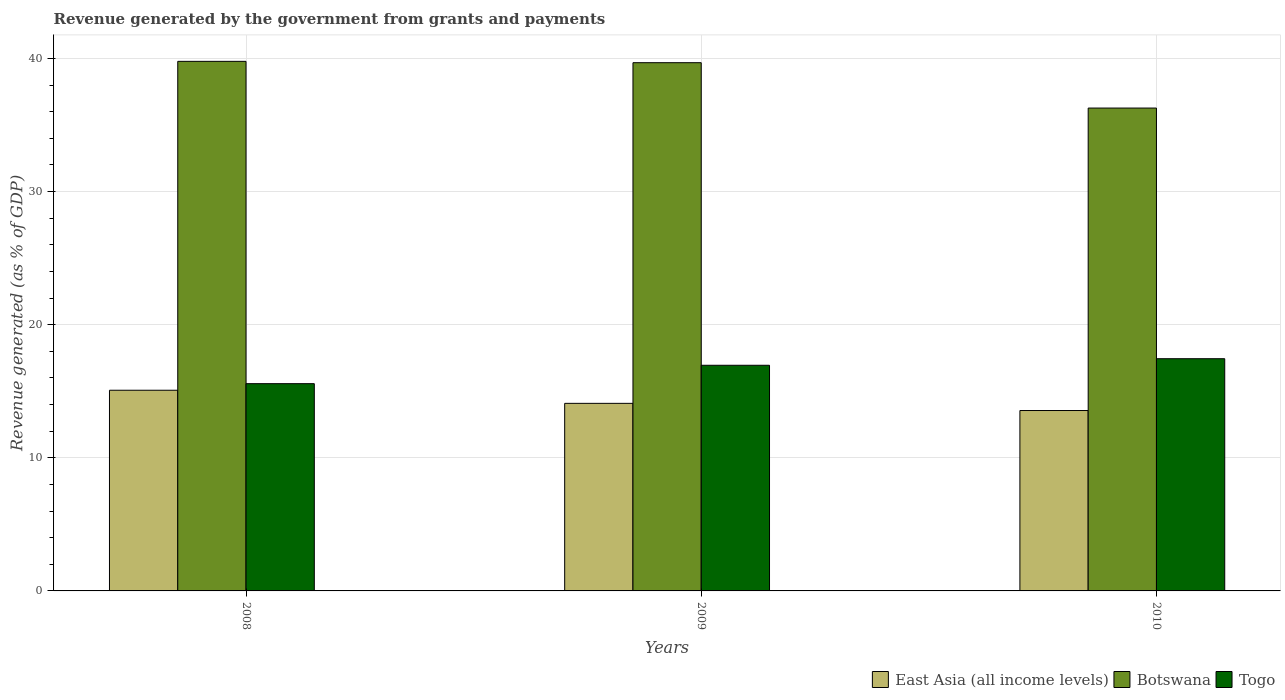How many different coloured bars are there?
Give a very brief answer. 3. What is the label of the 2nd group of bars from the left?
Provide a succinct answer. 2009. In how many cases, is the number of bars for a given year not equal to the number of legend labels?
Keep it short and to the point. 0. What is the revenue generated by the government in Togo in 2010?
Provide a succinct answer. 17.44. Across all years, what is the maximum revenue generated by the government in Botswana?
Your answer should be compact. 39.78. Across all years, what is the minimum revenue generated by the government in East Asia (all income levels)?
Give a very brief answer. 13.55. In which year was the revenue generated by the government in Botswana maximum?
Provide a short and direct response. 2008. In which year was the revenue generated by the government in East Asia (all income levels) minimum?
Provide a short and direct response. 2010. What is the total revenue generated by the government in Botswana in the graph?
Give a very brief answer. 115.74. What is the difference between the revenue generated by the government in East Asia (all income levels) in 2008 and that in 2009?
Give a very brief answer. 0.99. What is the difference between the revenue generated by the government in Togo in 2008 and the revenue generated by the government in Botswana in 2009?
Your answer should be very brief. -24.11. What is the average revenue generated by the government in Botswana per year?
Your answer should be very brief. 38.58. In the year 2010, what is the difference between the revenue generated by the government in Botswana and revenue generated by the government in Togo?
Offer a terse response. 18.83. In how many years, is the revenue generated by the government in East Asia (all income levels) greater than 10 %?
Your answer should be compact. 3. What is the ratio of the revenue generated by the government in Togo in 2009 to that in 2010?
Give a very brief answer. 0.97. What is the difference between the highest and the second highest revenue generated by the government in Togo?
Offer a very short reply. 0.49. What is the difference between the highest and the lowest revenue generated by the government in Togo?
Give a very brief answer. 1.87. In how many years, is the revenue generated by the government in East Asia (all income levels) greater than the average revenue generated by the government in East Asia (all income levels) taken over all years?
Make the answer very short. 1. Is the sum of the revenue generated by the government in Botswana in 2009 and 2010 greater than the maximum revenue generated by the government in Togo across all years?
Keep it short and to the point. Yes. What does the 3rd bar from the left in 2008 represents?
Your response must be concise. Togo. What does the 1st bar from the right in 2008 represents?
Give a very brief answer. Togo. Is it the case that in every year, the sum of the revenue generated by the government in Botswana and revenue generated by the government in East Asia (all income levels) is greater than the revenue generated by the government in Togo?
Your answer should be very brief. Yes. How many bars are there?
Make the answer very short. 9. Are all the bars in the graph horizontal?
Make the answer very short. No. How many years are there in the graph?
Your answer should be compact. 3. Are the values on the major ticks of Y-axis written in scientific E-notation?
Ensure brevity in your answer.  No. Does the graph contain grids?
Make the answer very short. Yes. Where does the legend appear in the graph?
Give a very brief answer. Bottom right. How many legend labels are there?
Ensure brevity in your answer.  3. How are the legend labels stacked?
Keep it short and to the point. Horizontal. What is the title of the graph?
Provide a short and direct response. Revenue generated by the government from grants and payments. Does "Algeria" appear as one of the legend labels in the graph?
Your response must be concise. No. What is the label or title of the Y-axis?
Keep it short and to the point. Revenue generated (as % of GDP). What is the Revenue generated (as % of GDP) in East Asia (all income levels) in 2008?
Your response must be concise. 15.07. What is the Revenue generated (as % of GDP) of Botswana in 2008?
Ensure brevity in your answer.  39.78. What is the Revenue generated (as % of GDP) in Togo in 2008?
Your answer should be very brief. 15.57. What is the Revenue generated (as % of GDP) in East Asia (all income levels) in 2009?
Ensure brevity in your answer.  14.09. What is the Revenue generated (as % of GDP) in Botswana in 2009?
Your response must be concise. 39.68. What is the Revenue generated (as % of GDP) of Togo in 2009?
Ensure brevity in your answer.  16.95. What is the Revenue generated (as % of GDP) in East Asia (all income levels) in 2010?
Ensure brevity in your answer.  13.55. What is the Revenue generated (as % of GDP) in Botswana in 2010?
Provide a succinct answer. 36.27. What is the Revenue generated (as % of GDP) of Togo in 2010?
Keep it short and to the point. 17.44. Across all years, what is the maximum Revenue generated (as % of GDP) of East Asia (all income levels)?
Provide a short and direct response. 15.07. Across all years, what is the maximum Revenue generated (as % of GDP) of Botswana?
Provide a succinct answer. 39.78. Across all years, what is the maximum Revenue generated (as % of GDP) in Togo?
Your answer should be compact. 17.44. Across all years, what is the minimum Revenue generated (as % of GDP) in East Asia (all income levels)?
Your answer should be compact. 13.55. Across all years, what is the minimum Revenue generated (as % of GDP) in Botswana?
Offer a very short reply. 36.27. Across all years, what is the minimum Revenue generated (as % of GDP) of Togo?
Offer a terse response. 15.57. What is the total Revenue generated (as % of GDP) in East Asia (all income levels) in the graph?
Make the answer very short. 42.72. What is the total Revenue generated (as % of GDP) of Botswana in the graph?
Keep it short and to the point. 115.74. What is the total Revenue generated (as % of GDP) of Togo in the graph?
Provide a succinct answer. 49.96. What is the difference between the Revenue generated (as % of GDP) of East Asia (all income levels) in 2008 and that in 2009?
Your answer should be compact. 0.99. What is the difference between the Revenue generated (as % of GDP) of Botswana in 2008 and that in 2009?
Your answer should be very brief. 0.1. What is the difference between the Revenue generated (as % of GDP) in Togo in 2008 and that in 2009?
Offer a terse response. -1.38. What is the difference between the Revenue generated (as % of GDP) of East Asia (all income levels) in 2008 and that in 2010?
Your answer should be compact. 1.52. What is the difference between the Revenue generated (as % of GDP) in Botswana in 2008 and that in 2010?
Keep it short and to the point. 3.51. What is the difference between the Revenue generated (as % of GDP) in Togo in 2008 and that in 2010?
Make the answer very short. -1.87. What is the difference between the Revenue generated (as % of GDP) in East Asia (all income levels) in 2009 and that in 2010?
Provide a short and direct response. 0.54. What is the difference between the Revenue generated (as % of GDP) of Botswana in 2009 and that in 2010?
Ensure brevity in your answer.  3.41. What is the difference between the Revenue generated (as % of GDP) of Togo in 2009 and that in 2010?
Ensure brevity in your answer.  -0.49. What is the difference between the Revenue generated (as % of GDP) in East Asia (all income levels) in 2008 and the Revenue generated (as % of GDP) in Botswana in 2009?
Keep it short and to the point. -24.61. What is the difference between the Revenue generated (as % of GDP) of East Asia (all income levels) in 2008 and the Revenue generated (as % of GDP) of Togo in 2009?
Offer a terse response. -1.88. What is the difference between the Revenue generated (as % of GDP) of Botswana in 2008 and the Revenue generated (as % of GDP) of Togo in 2009?
Provide a short and direct response. 22.83. What is the difference between the Revenue generated (as % of GDP) in East Asia (all income levels) in 2008 and the Revenue generated (as % of GDP) in Botswana in 2010?
Make the answer very short. -21.2. What is the difference between the Revenue generated (as % of GDP) in East Asia (all income levels) in 2008 and the Revenue generated (as % of GDP) in Togo in 2010?
Provide a succinct answer. -2.37. What is the difference between the Revenue generated (as % of GDP) of Botswana in 2008 and the Revenue generated (as % of GDP) of Togo in 2010?
Your response must be concise. 22.34. What is the difference between the Revenue generated (as % of GDP) in East Asia (all income levels) in 2009 and the Revenue generated (as % of GDP) in Botswana in 2010?
Provide a succinct answer. -22.18. What is the difference between the Revenue generated (as % of GDP) in East Asia (all income levels) in 2009 and the Revenue generated (as % of GDP) in Togo in 2010?
Give a very brief answer. -3.35. What is the difference between the Revenue generated (as % of GDP) of Botswana in 2009 and the Revenue generated (as % of GDP) of Togo in 2010?
Provide a short and direct response. 22.24. What is the average Revenue generated (as % of GDP) of East Asia (all income levels) per year?
Provide a short and direct response. 14.24. What is the average Revenue generated (as % of GDP) in Botswana per year?
Offer a very short reply. 38.58. What is the average Revenue generated (as % of GDP) in Togo per year?
Ensure brevity in your answer.  16.65. In the year 2008, what is the difference between the Revenue generated (as % of GDP) in East Asia (all income levels) and Revenue generated (as % of GDP) in Botswana?
Your response must be concise. -24.71. In the year 2008, what is the difference between the Revenue generated (as % of GDP) in East Asia (all income levels) and Revenue generated (as % of GDP) in Togo?
Provide a succinct answer. -0.49. In the year 2008, what is the difference between the Revenue generated (as % of GDP) of Botswana and Revenue generated (as % of GDP) of Togo?
Offer a terse response. 24.21. In the year 2009, what is the difference between the Revenue generated (as % of GDP) in East Asia (all income levels) and Revenue generated (as % of GDP) in Botswana?
Offer a terse response. -25.59. In the year 2009, what is the difference between the Revenue generated (as % of GDP) of East Asia (all income levels) and Revenue generated (as % of GDP) of Togo?
Your response must be concise. -2.86. In the year 2009, what is the difference between the Revenue generated (as % of GDP) of Botswana and Revenue generated (as % of GDP) of Togo?
Make the answer very short. 22.73. In the year 2010, what is the difference between the Revenue generated (as % of GDP) in East Asia (all income levels) and Revenue generated (as % of GDP) in Botswana?
Your answer should be compact. -22.72. In the year 2010, what is the difference between the Revenue generated (as % of GDP) of East Asia (all income levels) and Revenue generated (as % of GDP) of Togo?
Your response must be concise. -3.89. In the year 2010, what is the difference between the Revenue generated (as % of GDP) in Botswana and Revenue generated (as % of GDP) in Togo?
Your response must be concise. 18.83. What is the ratio of the Revenue generated (as % of GDP) of East Asia (all income levels) in 2008 to that in 2009?
Make the answer very short. 1.07. What is the ratio of the Revenue generated (as % of GDP) of Botswana in 2008 to that in 2009?
Offer a terse response. 1. What is the ratio of the Revenue generated (as % of GDP) in Togo in 2008 to that in 2009?
Ensure brevity in your answer.  0.92. What is the ratio of the Revenue generated (as % of GDP) in East Asia (all income levels) in 2008 to that in 2010?
Provide a succinct answer. 1.11. What is the ratio of the Revenue generated (as % of GDP) of Botswana in 2008 to that in 2010?
Provide a succinct answer. 1.1. What is the ratio of the Revenue generated (as % of GDP) of Togo in 2008 to that in 2010?
Provide a short and direct response. 0.89. What is the ratio of the Revenue generated (as % of GDP) in East Asia (all income levels) in 2009 to that in 2010?
Offer a very short reply. 1.04. What is the ratio of the Revenue generated (as % of GDP) of Botswana in 2009 to that in 2010?
Offer a terse response. 1.09. What is the ratio of the Revenue generated (as % of GDP) of Togo in 2009 to that in 2010?
Offer a terse response. 0.97. What is the difference between the highest and the second highest Revenue generated (as % of GDP) of East Asia (all income levels)?
Ensure brevity in your answer.  0.99. What is the difference between the highest and the second highest Revenue generated (as % of GDP) in Botswana?
Make the answer very short. 0.1. What is the difference between the highest and the second highest Revenue generated (as % of GDP) of Togo?
Provide a succinct answer. 0.49. What is the difference between the highest and the lowest Revenue generated (as % of GDP) in East Asia (all income levels)?
Ensure brevity in your answer.  1.52. What is the difference between the highest and the lowest Revenue generated (as % of GDP) of Botswana?
Offer a very short reply. 3.51. What is the difference between the highest and the lowest Revenue generated (as % of GDP) in Togo?
Keep it short and to the point. 1.87. 